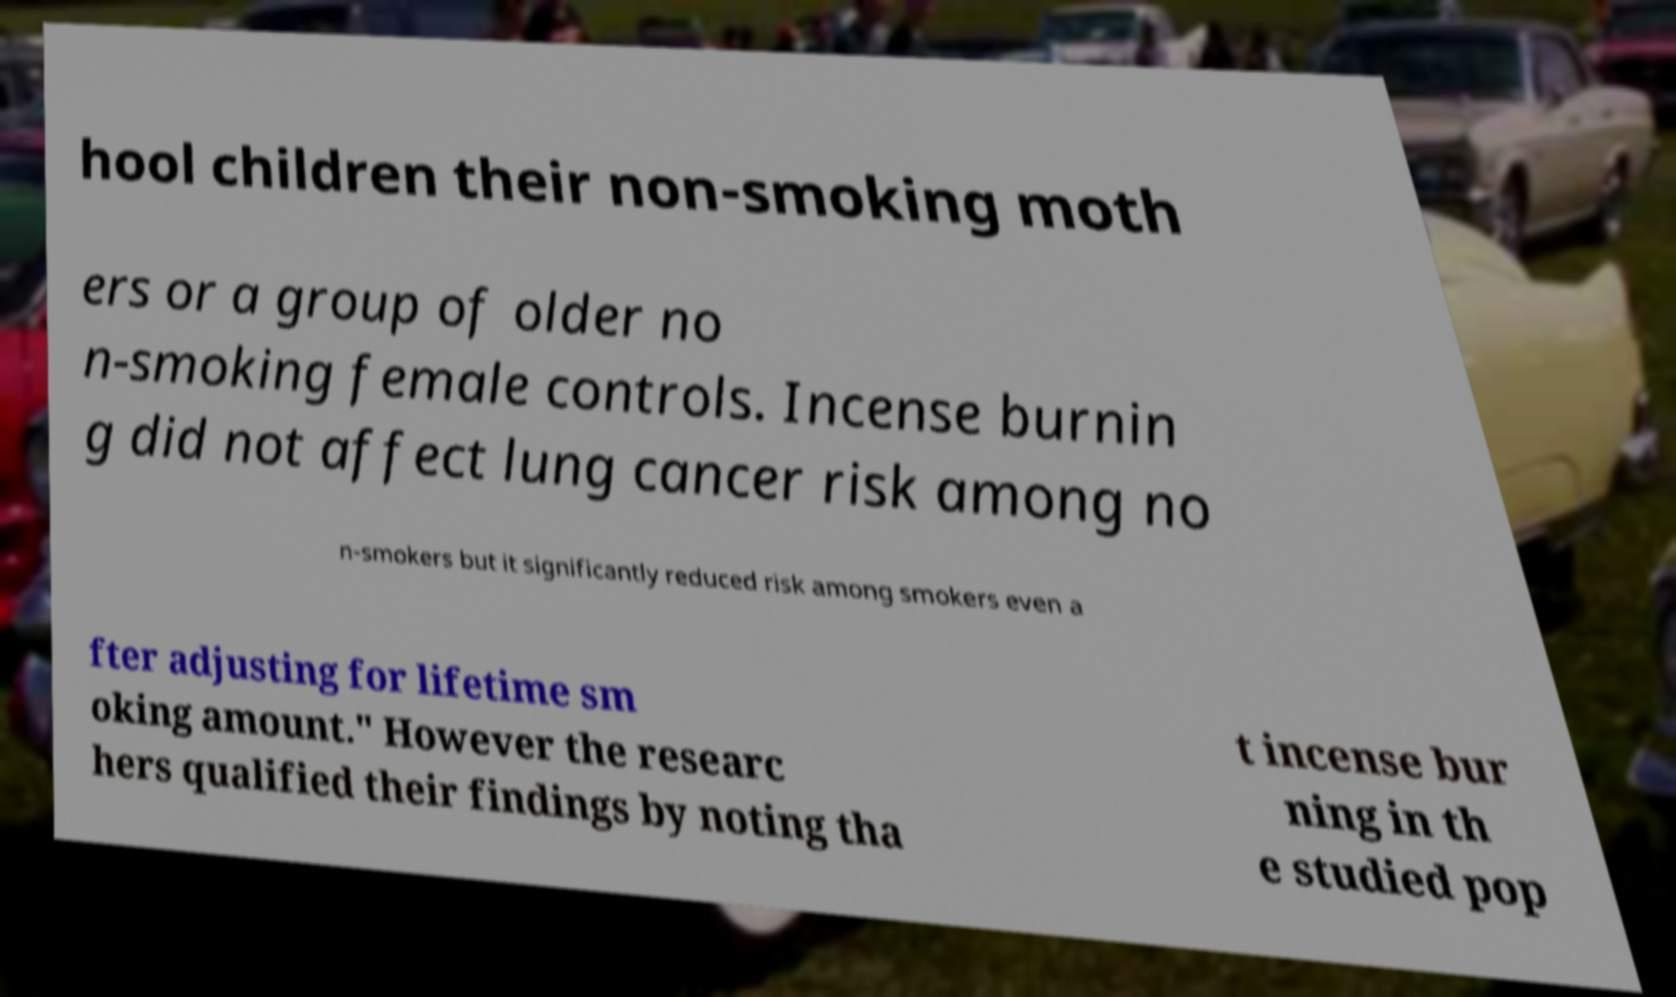There's text embedded in this image that I need extracted. Can you transcribe it verbatim? hool children their non-smoking moth ers or a group of older no n-smoking female controls. Incense burnin g did not affect lung cancer risk among no n-smokers but it significantly reduced risk among smokers even a fter adjusting for lifetime sm oking amount." However the researc hers qualified their findings by noting tha t incense bur ning in th e studied pop 